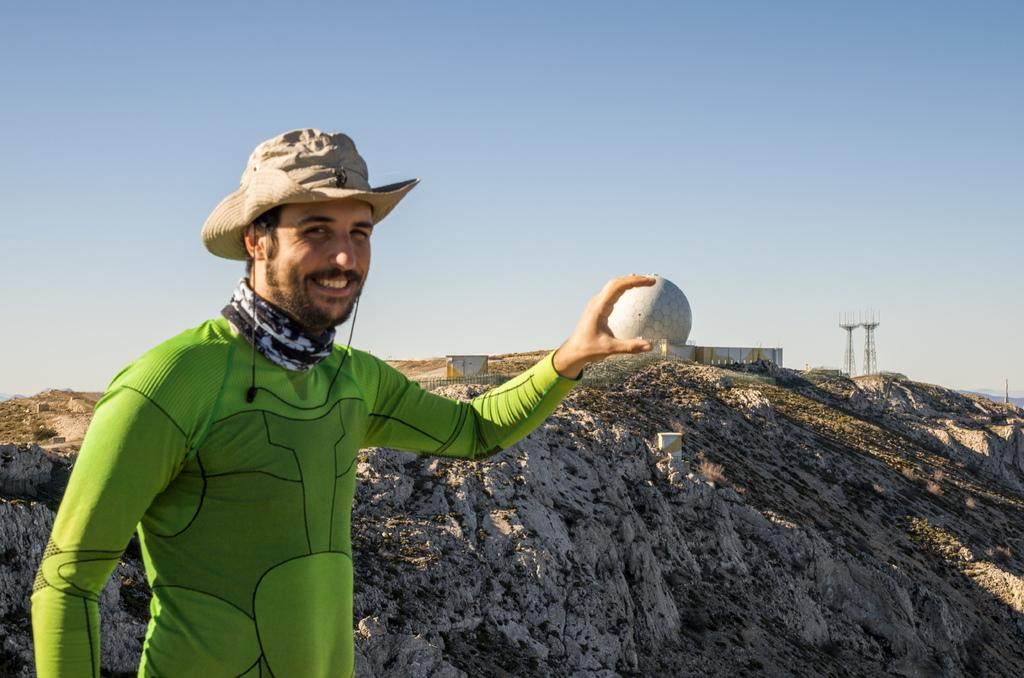What is the main subject of the image? There is a person standing in the middle of the image. What is the person doing in the image? The person is smiling. What can be seen in the background of the image? There is a hill in the background of the image, with buildings and poles on it. What is visible at the top of the image? The sky is visible at the top of the image. What type of beef is being served in the image? There is no beef present in the image; it features a person standing on a hill with buildings and poles in the background. How many ladybugs can be seen on the person's clothing in the image? There are no ladybugs visible on the person's clothing in the image. 